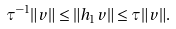<formula> <loc_0><loc_0><loc_500><loc_500>\tau ^ { - 1 } \| v \| \leq \| h _ { 1 } v \| \leq \tau \| v \| .</formula> 